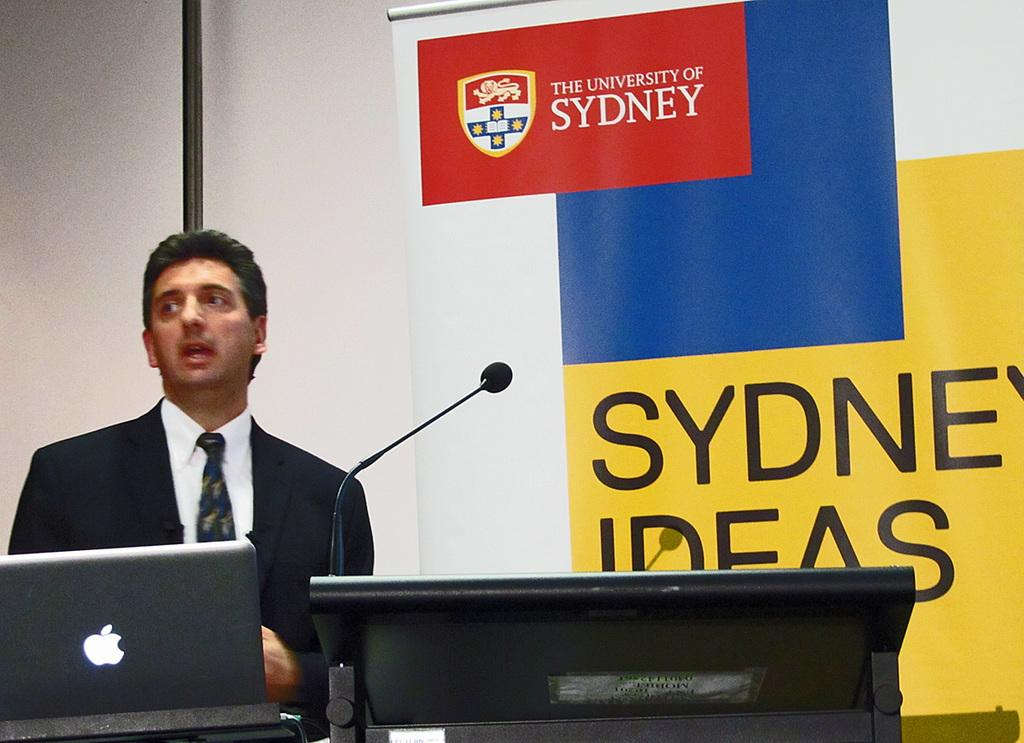Who is present in the image? There is a man in the image. What object is in front of the man? There is a laptop in front of the man. What type of equipment is visible in the image? There is a mic on a stand in the image. What can be seen in the background of the image? There is a banner with an emblem and text in the background of the image. What type of cart is being used to transport the appliance in the image? There is no cart or appliance present in the image. 